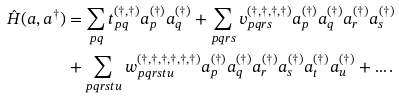Convert formula to latex. <formula><loc_0><loc_0><loc_500><loc_500>\hat { H } ( a , a ^ { \dag } ) & = \sum _ { p q } t ^ { ( \dag , \dag ) } _ { p q } a ^ { ( \dag ) } _ { p } a ^ { ( \dag ) } _ { q } + \sum _ { p q r s } v ^ { ( \dag , \dag , \dag , \dag ) } _ { p q r s } a ^ { ( \dag ) } _ { p } a ^ { ( \dag ) } _ { q } a ^ { ( \dag ) } _ { r } a ^ { ( \dag ) } _ { s } \\ & + \sum _ { p q r s t u } w _ { p q r s t u } ^ { ( \dag , \dag , \dag , \dag , \dag , \dag ) } a ^ { ( \dag ) } _ { p } a ^ { ( \dag ) } _ { q } a ^ { ( \dag ) } _ { r } a ^ { ( \dag ) } _ { s } a ^ { ( \dag ) } _ { t } a ^ { ( \dag ) } _ { u } + \dots .</formula> 